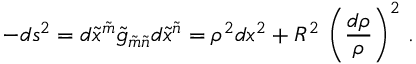Convert formula to latex. <formula><loc_0><loc_0><loc_500><loc_500>- d s ^ { 2 } = d \tilde { x } ^ { \tilde { m } } \tilde { g } _ { \tilde { m } \tilde { n } } d \tilde { x } ^ { \tilde { n } } = \rho ^ { 2 } d x ^ { 2 } + R ^ { 2 } \, \left ( \frac { d \rho } \rho \right ) ^ { 2 } \, .</formula> 